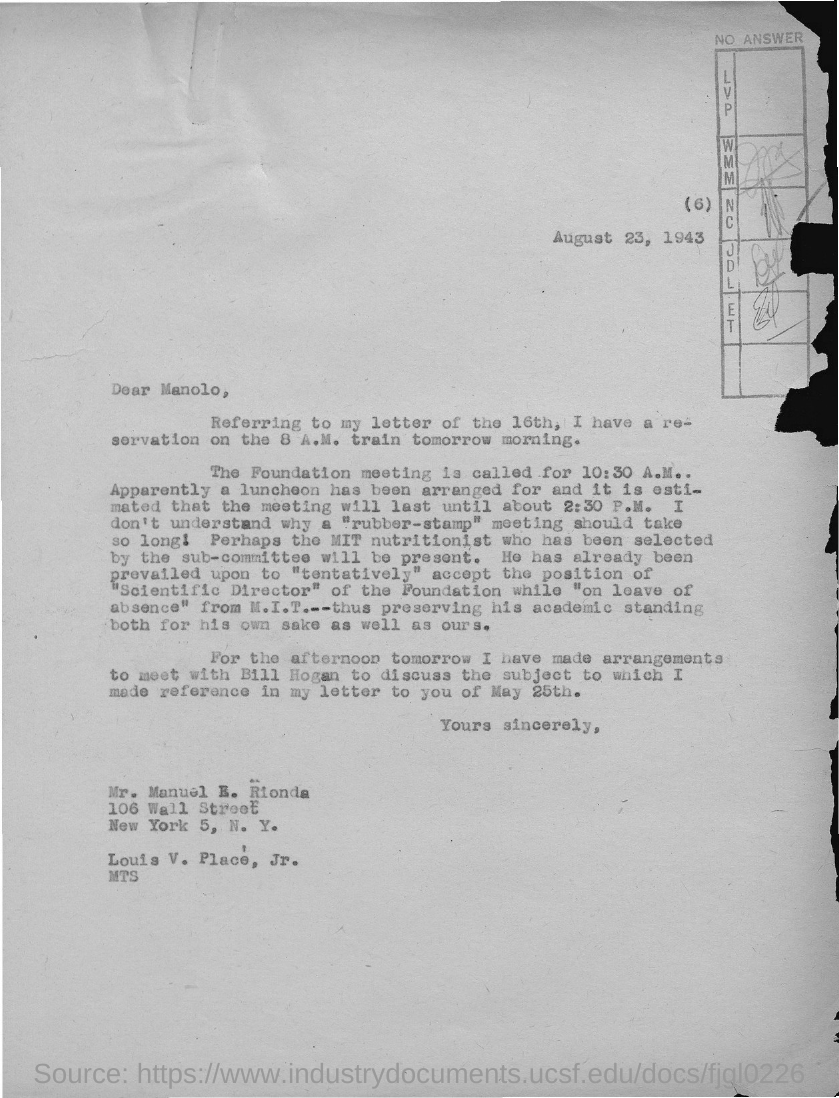What is the date on the document?
Keep it short and to the point. August 23, 1943. To Whom is this letter addressed to?
Keep it short and to the point. Mr. Manuel E. Rionda. Which letter are they referring to?
Make the answer very short. Letter of the 16th. When is the Foundation meeting called?
Ensure brevity in your answer.  10:30 A.M. Till when is the meeting going to last?
Make the answer very short. Until about 2.30 p.m. Who have they arranged a meeting with?
Make the answer very short. Bill Hogan. 